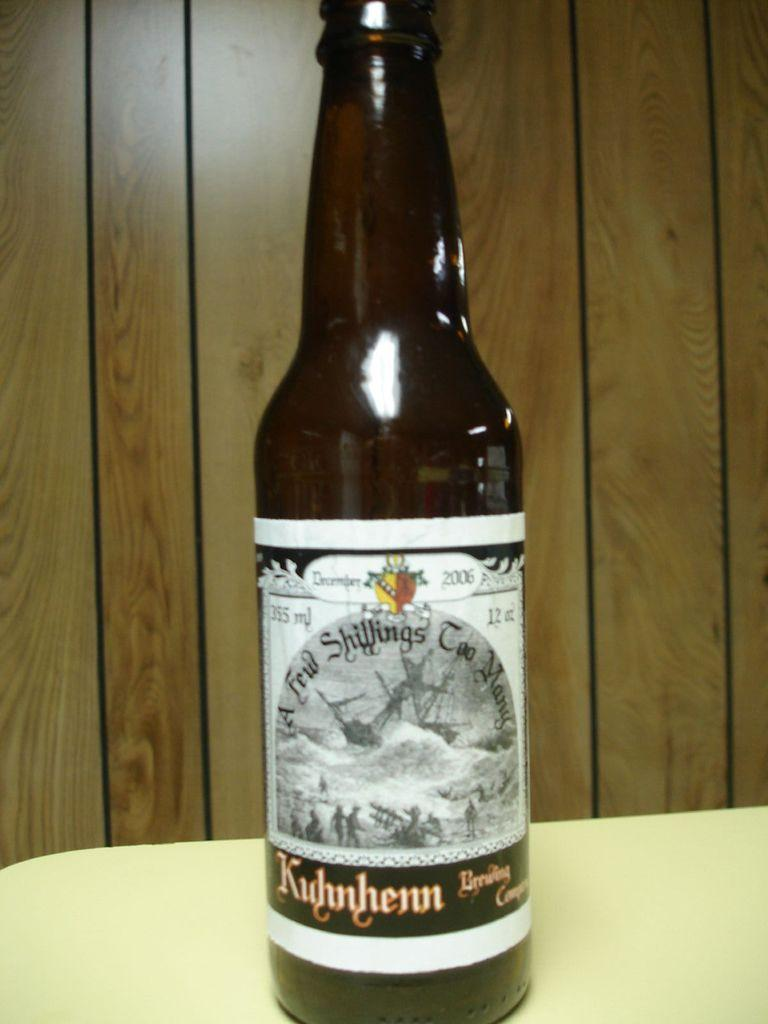<image>
Provide a brief description of the given image. A bottle is labeled with the year 2006. 